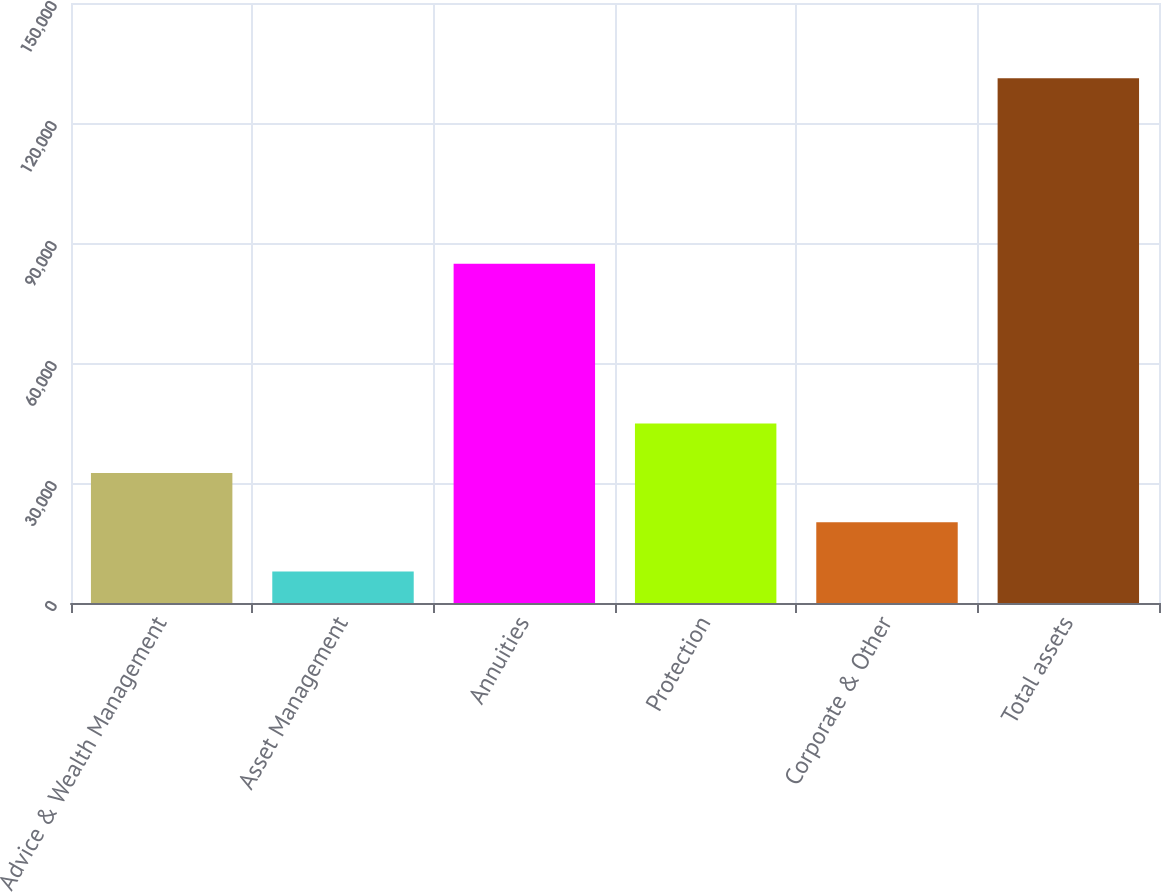Convert chart. <chart><loc_0><loc_0><loc_500><loc_500><bar_chart><fcel>Advice & Wealth Management<fcel>Asset Management<fcel>Annuities<fcel>Protection<fcel>Corporate & Other<fcel>Total assets<nl><fcel>32526<fcel>7854<fcel>84836<fcel>44862<fcel>20190<fcel>131214<nl></chart> 